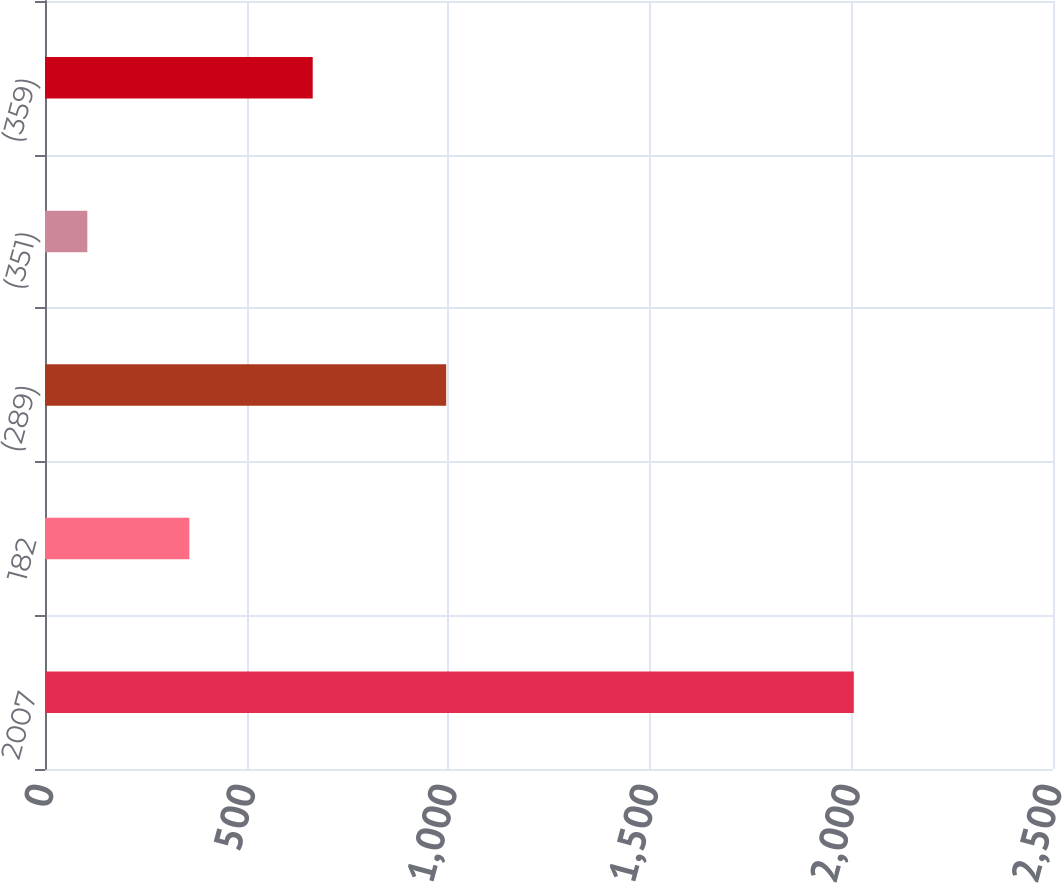Convert chart. <chart><loc_0><loc_0><loc_500><loc_500><bar_chart><fcel>2007<fcel>182<fcel>(289)<fcel>(351)<fcel>(359)<nl><fcel>2006<fcel>358<fcel>995<fcel>105<fcel>664<nl></chart> 